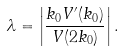<formula> <loc_0><loc_0><loc_500><loc_500>\lambda = \left | \frac { k _ { 0 } V ^ { \prime } ( k _ { 0 } ) } { V ( 2 k _ { 0 } ) } \right | .</formula> 